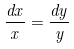<formula> <loc_0><loc_0><loc_500><loc_500>\frac { d x } { x } = \frac { d y } { y }</formula> 